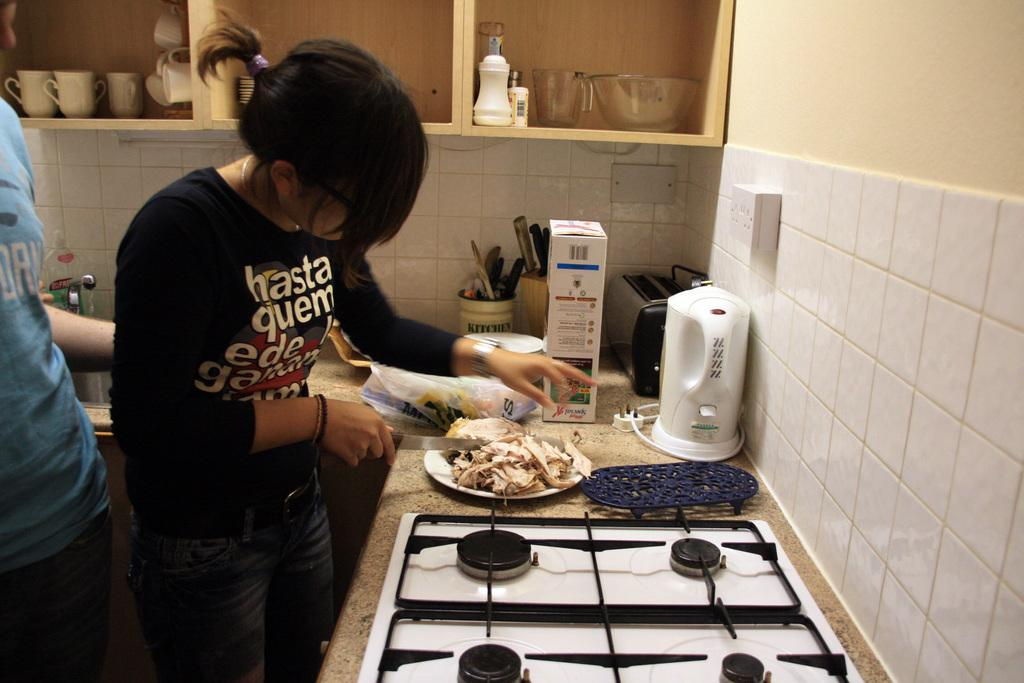<image>
Summarize the visual content of the image. A woman with hasta quem written on her shirt uses a knife to prepare food. 